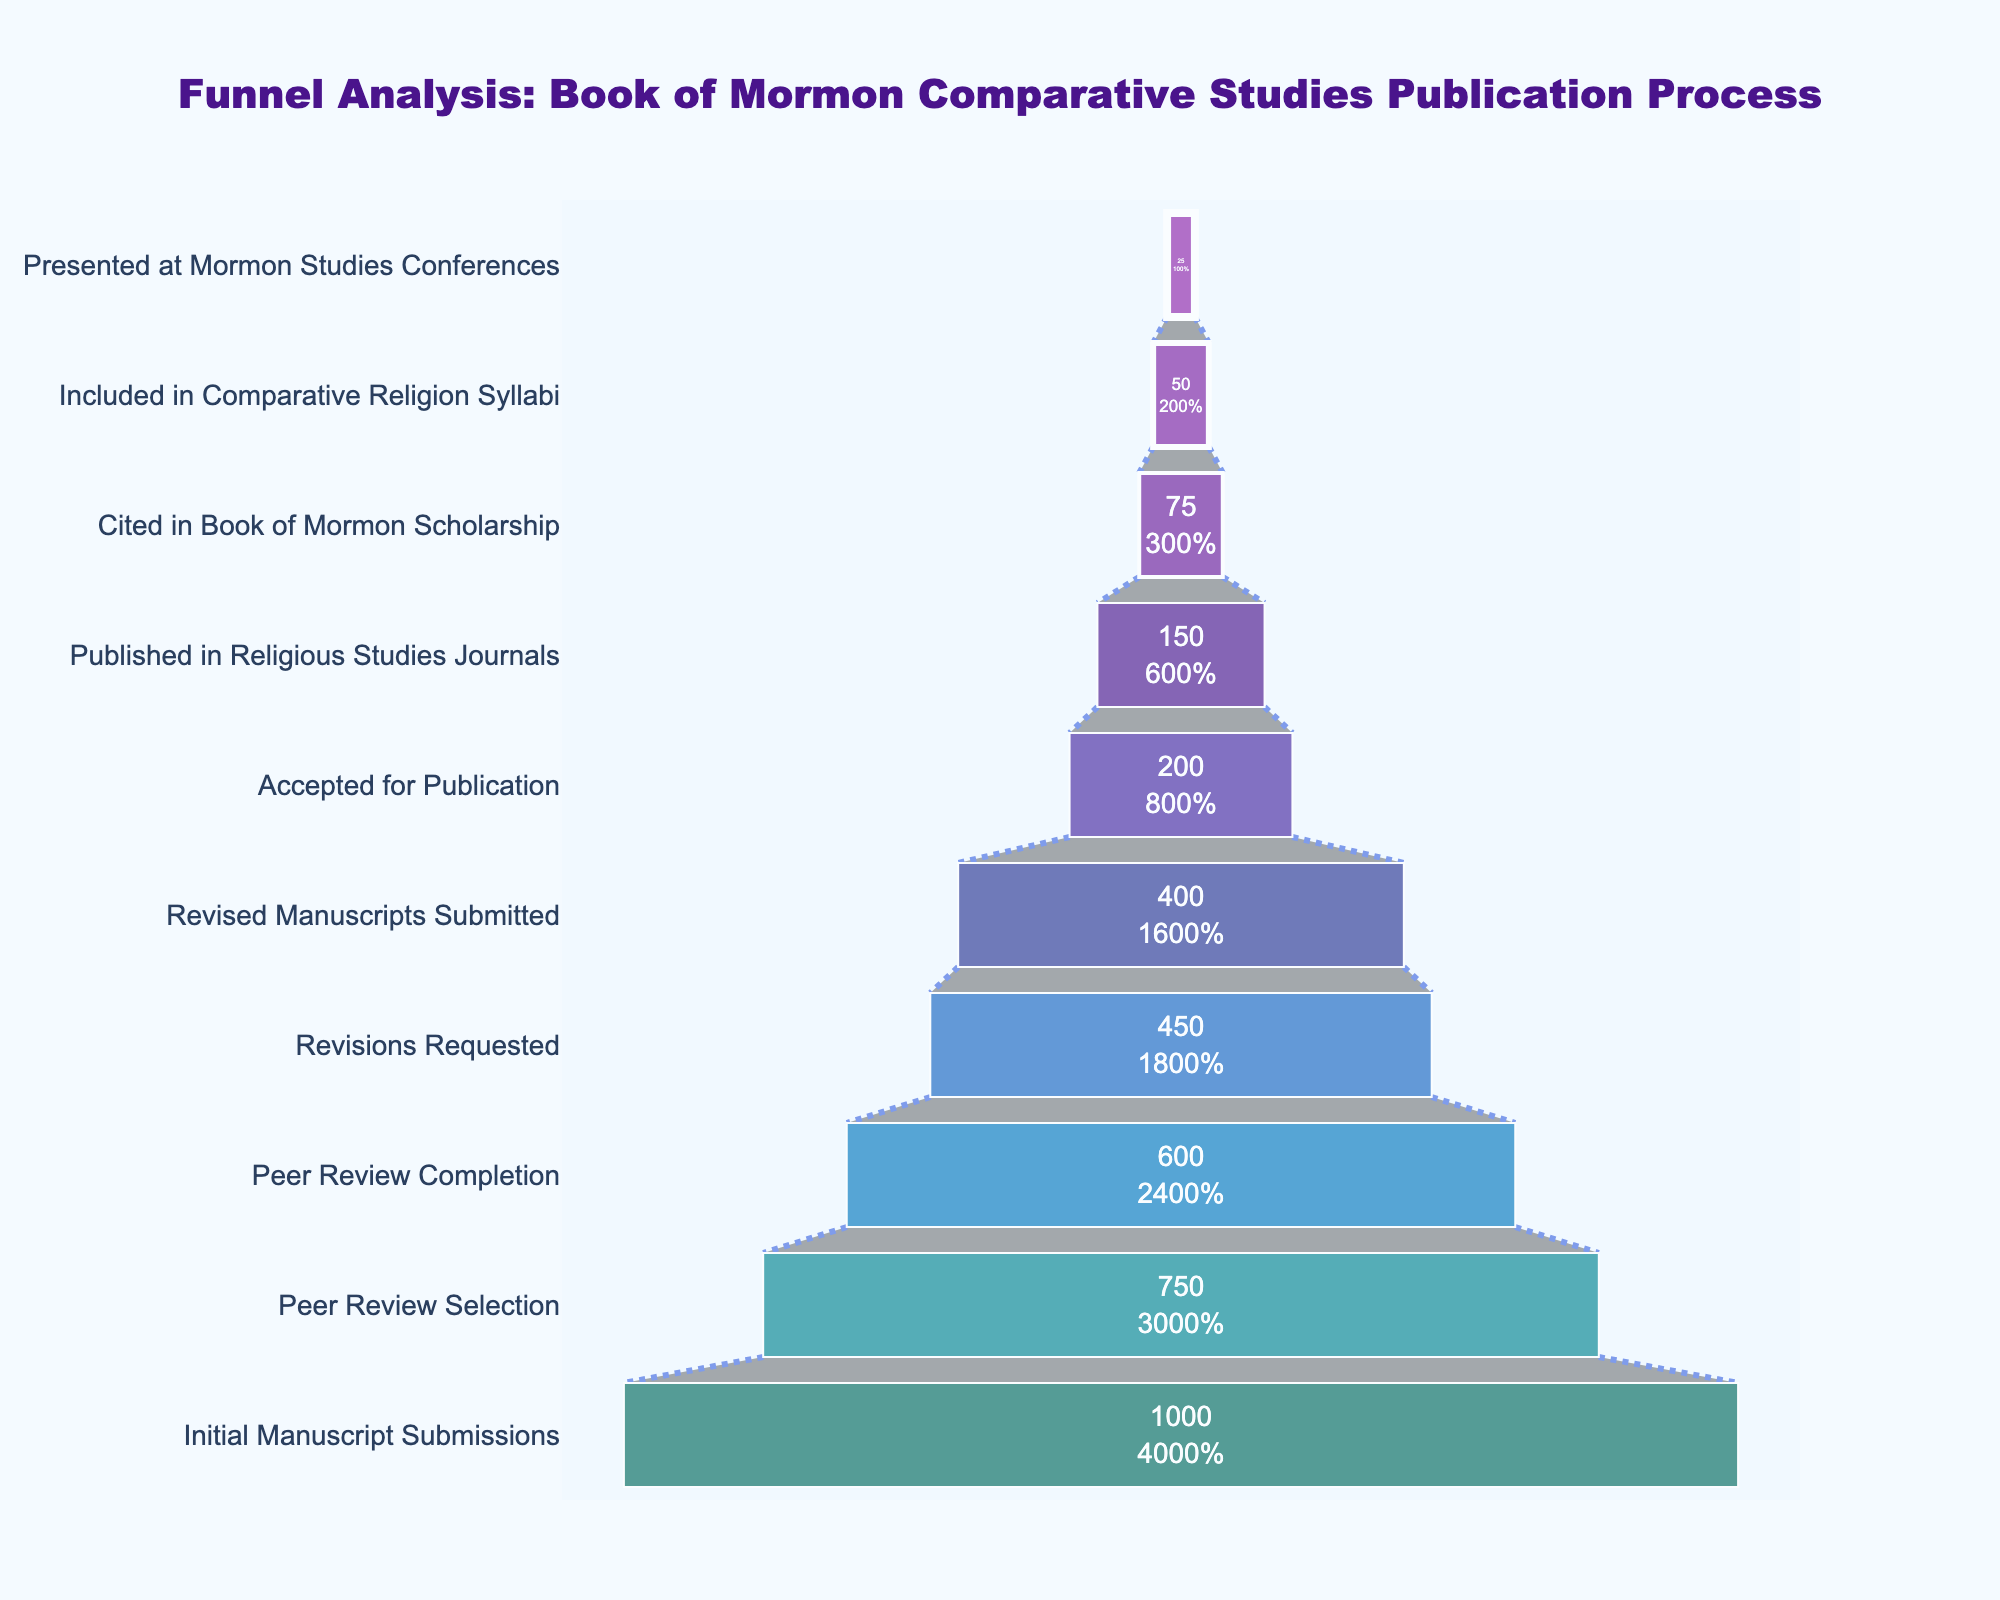What's the title of the figure? The title of the figure is located at the top and is prominently displayed. The title helps users understand the context of the chart.
Answer: Funnel Analysis: Book of Mormon Comparative Studies Publication Process What stage has the highest count? The highest count can be seen at the top of the funnel chart since the chart is inverted. The first stage listed at the top has the highest count of 1000.
Answer: Initial Manuscript Submissions What is the percentage drop from initial manuscript submissions to peer review selection? The drop percentage can be found by subtracting the count of peer review selection from the initial manuscript submissions, then dividing by the initial count and multiplying by 100. ((1000 - 750)/1000) * 100 = 25%.
Answer: 25% Which stage has exactly half the count of manuscripts compared to the revised manuscripts submitted stage? The revised manuscripts submitted stage has a count of 400. The stage with half of this count is accepted for publication, which has a count of 200.
Answer: Accepted for Publication How many articles were ultimately published in religious studies journals? To find the number of articles published in religious studies journals, look at the corresponding stage in the funnel chart.
Answer: 150 What is the percentage of manuscripts that were published in religious studies journals out of those initially submitted? To calculate this, divide the count of published articles by the count of initial manuscript submissions and multiply by 100. (150/1000) * 100 = 15%.
Answer: 15% Which stage saw the smallest drop in count from the previous stage? Observing the stages, the smallest drop is from revisions requested (450) to revised manuscripts submitted (400), a drop of 50.
Answer: Revised Manuscripts Submitted What is the difference in count between manuscripts that were accepted for publication and those that were cited in Book of Mormon scholarship? This involves a simple subtraction of the counts. 200 - 75 = 125.
Answer: 125 What percentage of the manuscripts presented at Mormon studies conferences were initially submitted? This is calculated by dividing the final count in the funnel by the initial count and multiplying by 100. (25/1000) * 100 = 2.5%.
Answer: 2.5% Between which stages does the largest count drop occur? By examining the differences between consecutive stages, the largest drop is from revised manuscripts submitted (400) to accepted for publication (200), a drop of 200.
Answer: Revised Manuscripts Submitted to Accepted for Publication 